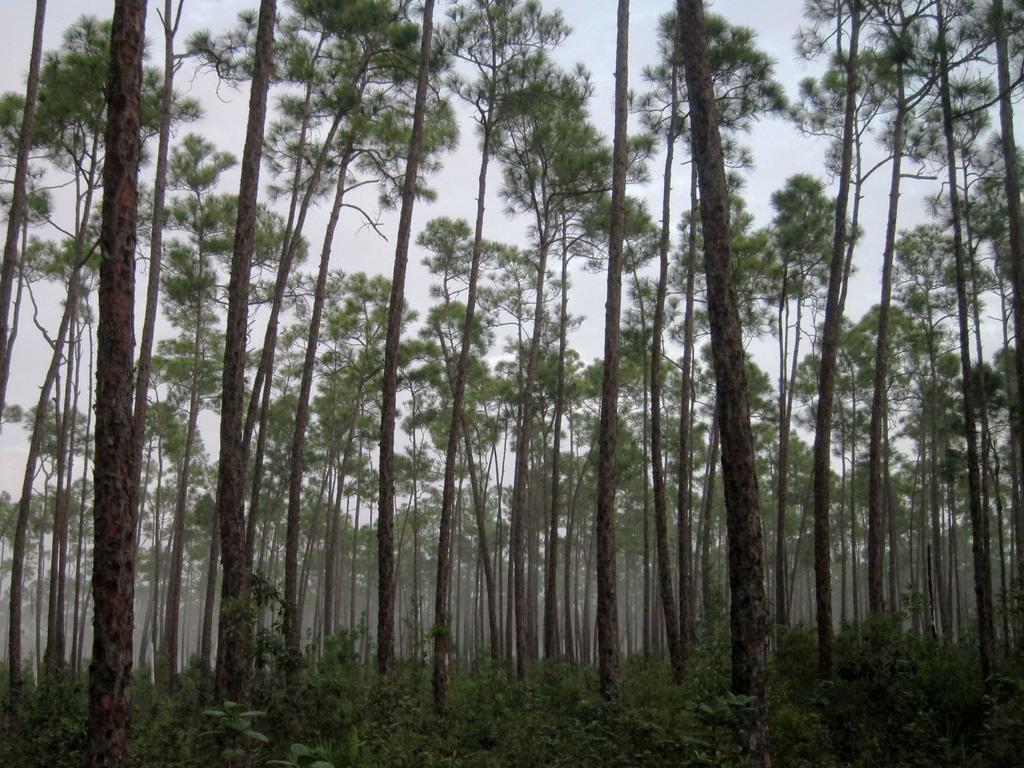What type of vegetation can be seen in the image? There are plants and trees in the image. What atmospheric condition is visible in the image? There is fog visible in the image. What is visible in the background of the image? The sky is plain and visible in the background of the image. Can you see a door in the image? There is no door present in the image. What type of utensil can be seen in the image? There are no utensils present in the image. Is there any indication of a space-related object or setting in the image? There is no indication of a space-related object or setting in the image. 